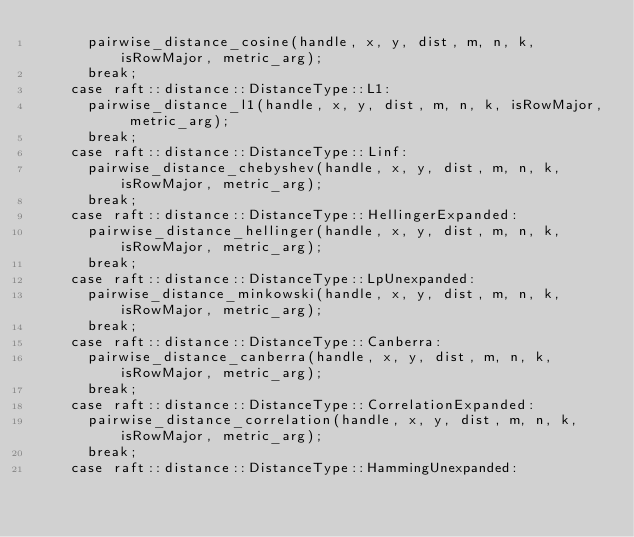Convert code to text. <code><loc_0><loc_0><loc_500><loc_500><_Cuda_>      pairwise_distance_cosine(handle, x, y, dist, m, n, k, isRowMajor, metric_arg);
      break;
    case raft::distance::DistanceType::L1:
      pairwise_distance_l1(handle, x, y, dist, m, n, k, isRowMajor, metric_arg);
      break;
    case raft::distance::DistanceType::Linf:
      pairwise_distance_chebyshev(handle, x, y, dist, m, n, k, isRowMajor, metric_arg);
      break;
    case raft::distance::DistanceType::HellingerExpanded:
      pairwise_distance_hellinger(handle, x, y, dist, m, n, k, isRowMajor, metric_arg);
      break;
    case raft::distance::DistanceType::LpUnexpanded:
      pairwise_distance_minkowski(handle, x, y, dist, m, n, k, isRowMajor, metric_arg);
      break;
    case raft::distance::DistanceType::Canberra:
      pairwise_distance_canberra(handle, x, y, dist, m, n, k, isRowMajor, metric_arg);
      break;
    case raft::distance::DistanceType::CorrelationExpanded:
      pairwise_distance_correlation(handle, x, y, dist, m, n, k, isRowMajor, metric_arg);
      break;
    case raft::distance::DistanceType::HammingUnexpanded:</code> 